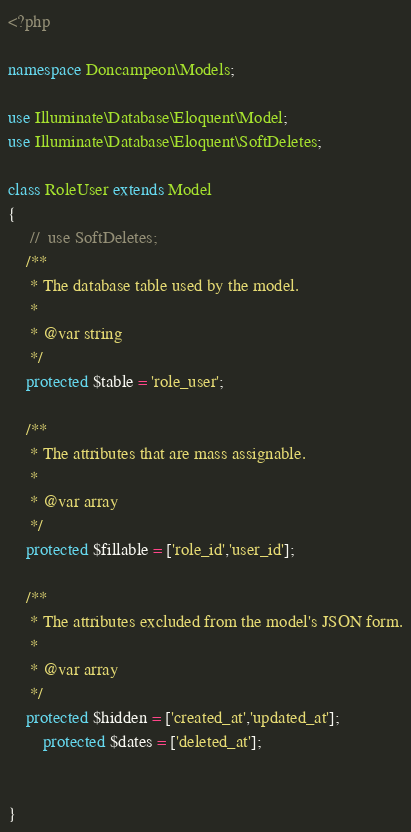<code> <loc_0><loc_0><loc_500><loc_500><_PHP_><?php

namespace Doncampeon\Models;

use Illuminate\Database\Eloquent\Model;
use Illuminate\Database\Eloquent\SoftDeletes;

class RoleUser extends Model
{
     //  use SoftDeletes;
    /**
     * The database table used by the model.
     *
     * @var string
     */
    protected $table = 'role_user';

    /**
     * The attributes that are mass assignable.
     *
     * @var array
     */
    protected $fillable = ['role_id','user_id'];

    /**
     * The attributes excluded from the model's JSON form.
     *
     * @var array
     */
    protected $hidden = ['created_at','updated_at'];
        protected $dates = ['deleted_at'];

      
}
</code> 